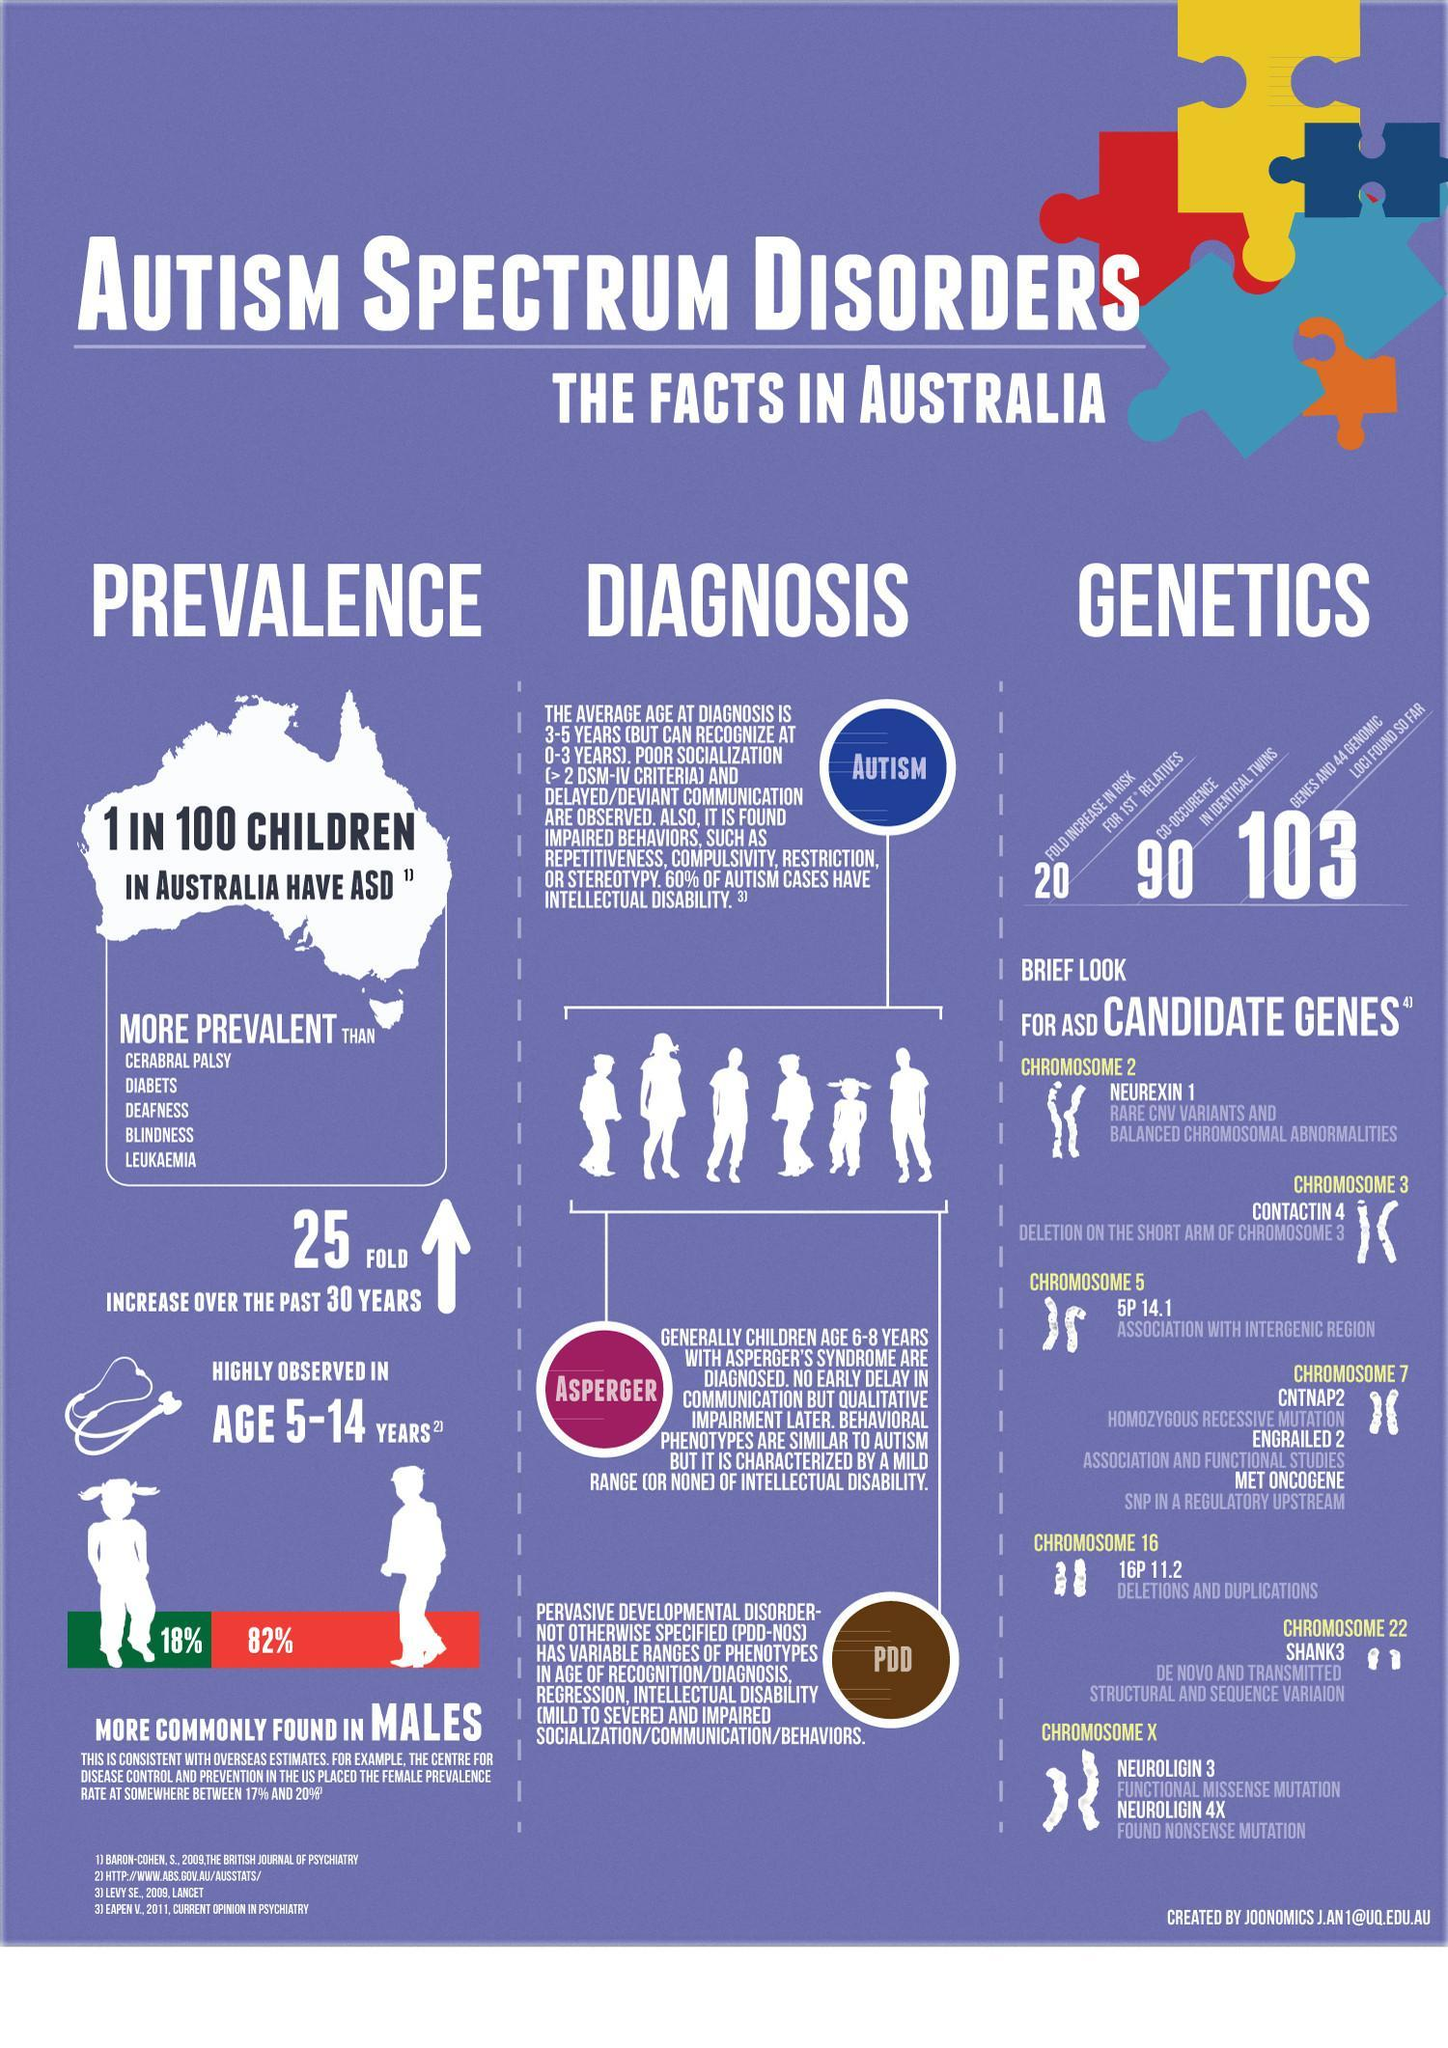What percentage of males in the age of 5-14 years have autism in Australia?
Answer the question with a short phrase. 82% What percentage of females in the age of 5-14 years have autism in Australia? 18% 